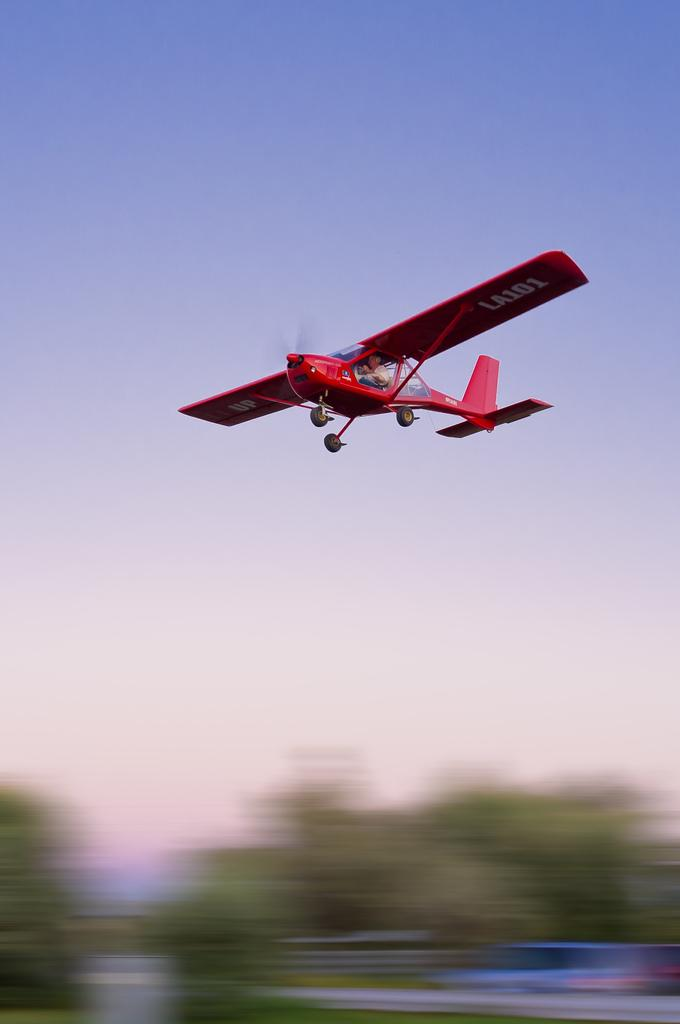What is the main subject of the image? The main subject of the image is an airplane. What is the airplane doing in the image? The airplane is flying in the air. How would you describe the sky in the image? The sky is clear in the image. What type of vegetation can be seen in the image, although it appears blurry? Trees are visible in the image, but they appear blurry. What type of income can be seen on the airplane's wings in the image? There is no income visible on the airplane's wings in the image. Can you tell me how many stamps are on the airplane's tail in the image? There are no stamps present on the airplane's tail in the image. 